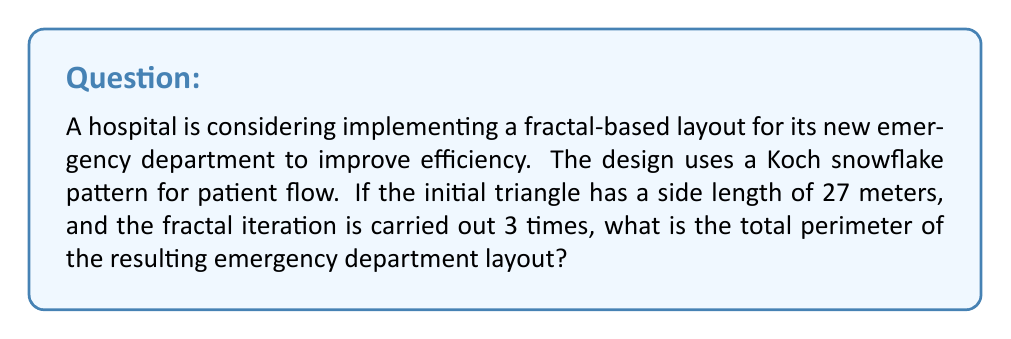Teach me how to tackle this problem. Let's approach this step-by-step:

1) The Koch snowflake is created by starting with an equilateral triangle and then repeatedly replacing the middle third of each line segment with an equilateral triangle.

2) The perimeter of the Koch snowflake after n iterations is given by the formula:

   $$P_n = 3 \cdot L \cdot (\frac{4}{3})^n$$

   Where L is the initial side length and n is the number of iterations.

3) In this case:
   L = 27 meters
   n = 3 iterations

4) Let's substitute these values into our formula:

   $$P_3 = 3 \cdot 27 \cdot (\frac{4}{3})^3$$

5) Let's solve the exponent first:

   $$(\frac{4}{3})^3 = \frac{64}{27}$$

6) Now our equation looks like this:

   $$P_3 = 3 \cdot 27 \cdot \frac{64}{27}$$

7) The 27's cancel out:

   $$P_3 = 3 \cdot 64 = 192$$

Therefore, the total perimeter of the emergency department layout after 3 iterations of the Koch snowflake pattern is 192 meters.
Answer: 192 meters 